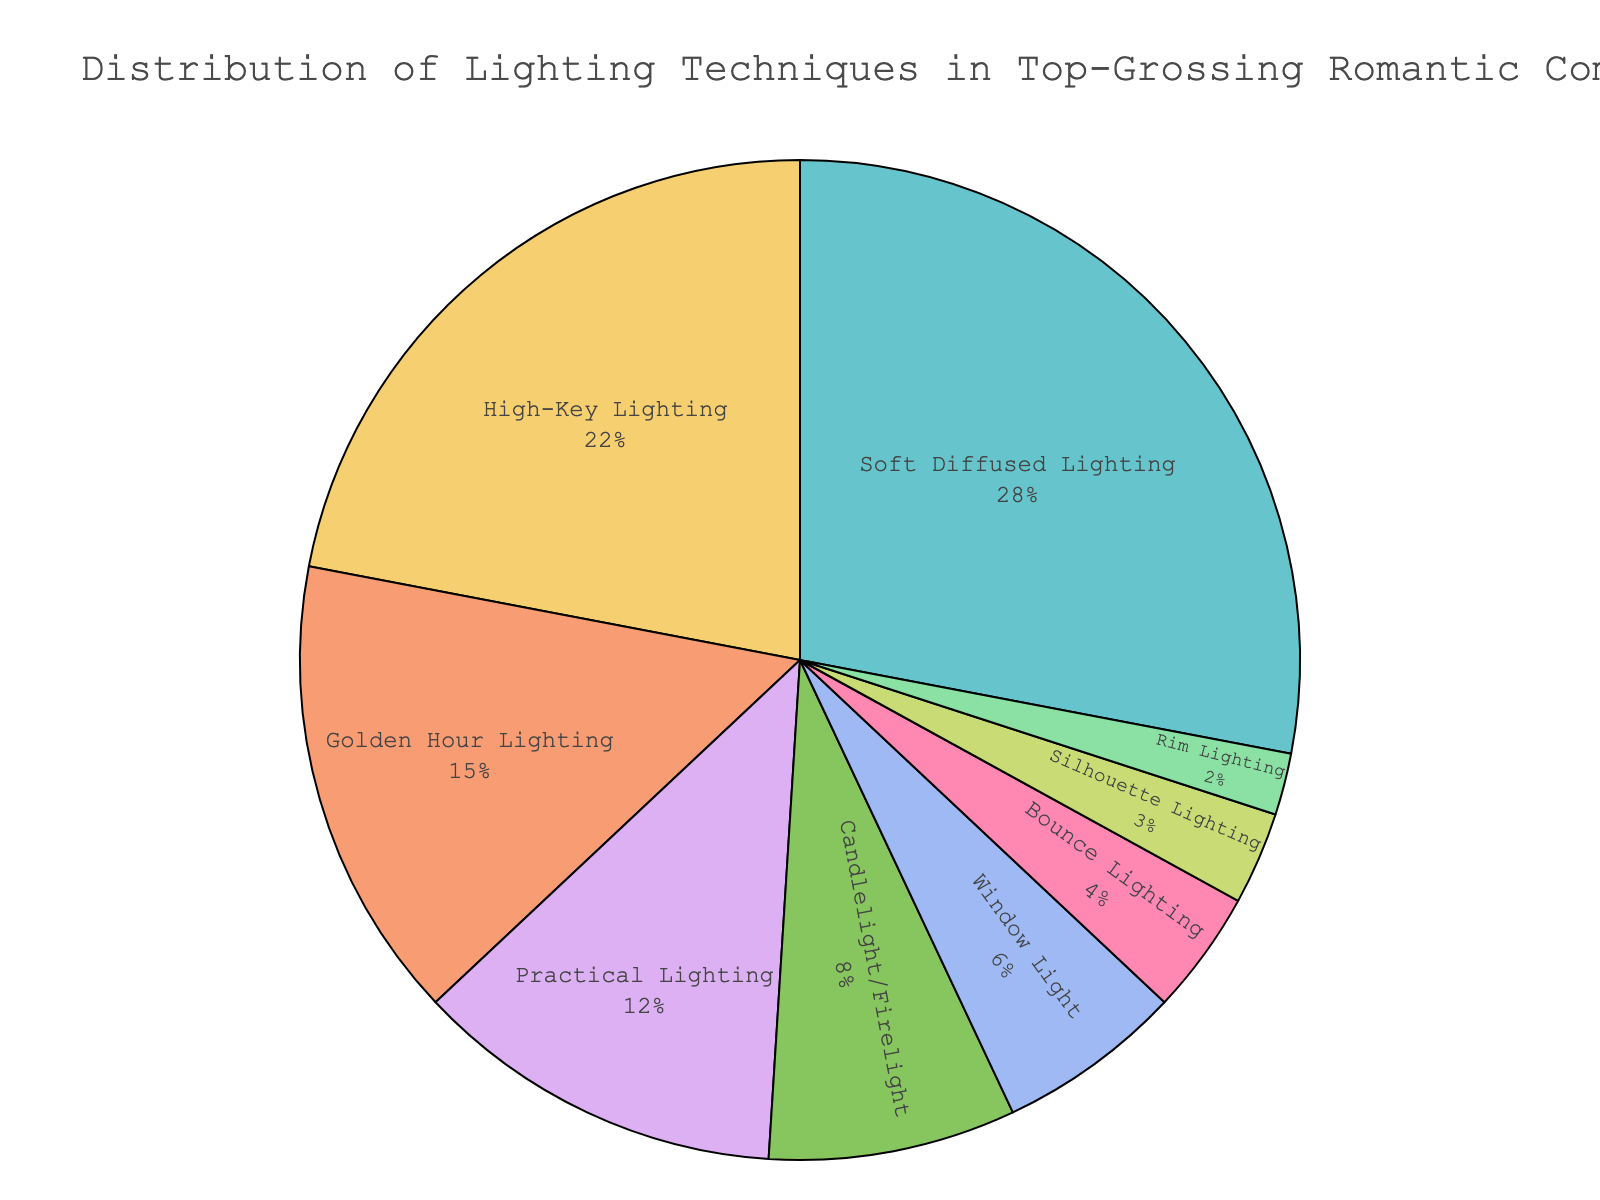What lighting technique is used most often in top-grossing romantic comedies? The pie chart shows the percentage distribution of different lighting techniques. The largest segment of the chart corresponds to "Soft Diffused Lighting" with 28%.
Answer: Soft Diffused Lighting How much more frequent is Soft Diffused Lighting compared to High-Key Lighting? Soft Diffused Lighting is used 28% of the time, while High-Key Lighting is used 22% of the time. The difference is 28 - 22 = 6%.
Answer: 6% What percentage of lighting techniques falls under 10% usage? Summing up Candlelight/Firelight (8%), Window Light (6%), Bounce Lighting (4%), Silhouette Lighting (3%), and Rim Lighting (2%) gives a total of 8 + 6 + 4 + 3 + 2 = 23%.
Answer: 23% Which lighting technique is represented by the smallest segment on the chart? The smallest segment represents Rim Lighting with 2%.
Answer: Rim Lighting Is Golden Hour Lighting used more often than Practical Lighting? According to the chart, Golden Hour Lighting is used 15% of the time, while Practical Lighting is used 12% of the time. Therefore, Golden Hour Lighting is used more often.
Answer: Yes What is the combined percentage of the top two most frequently used lighting techniques? The top two lighting techniques are Soft Diffused Lighting (28%) and High-Key Lighting (22%). Their combined percentage is 28 + 22 = 50%.
Answer: 50% What technique falls between 10% and 15% usage, according to the chart? The chart shows Practical Lighting (12%) falling between 10% and 15%.
Answer: Practical Lighting How much more frequent is the highest used technique compared to the least used technique? The highest used technique is Soft Diffused Lighting at 28%. The least used technique is Rim Lighting at 2%. The difference is 28 - 2 = 26%.
Answer: 26% What percentage of the lighting techniques are used less frequently than 12%? Summing up Candlelight/Firelight (8%), Window Light (6%), Bounce Lighting (4%), Silhouette Lighting (3%), and Rim Lighting (2%) gives a total of 8 + 6 + 4 + 3 + 2 = 23%.
Answer: 23% What percentage do the least frequent two techniques represent together? The least frequent two techniques are Silhouette Lighting (3%) and Rim Lighting (2%). Their combined percentage is 3 + 2 = 5%.
Answer: 5% 